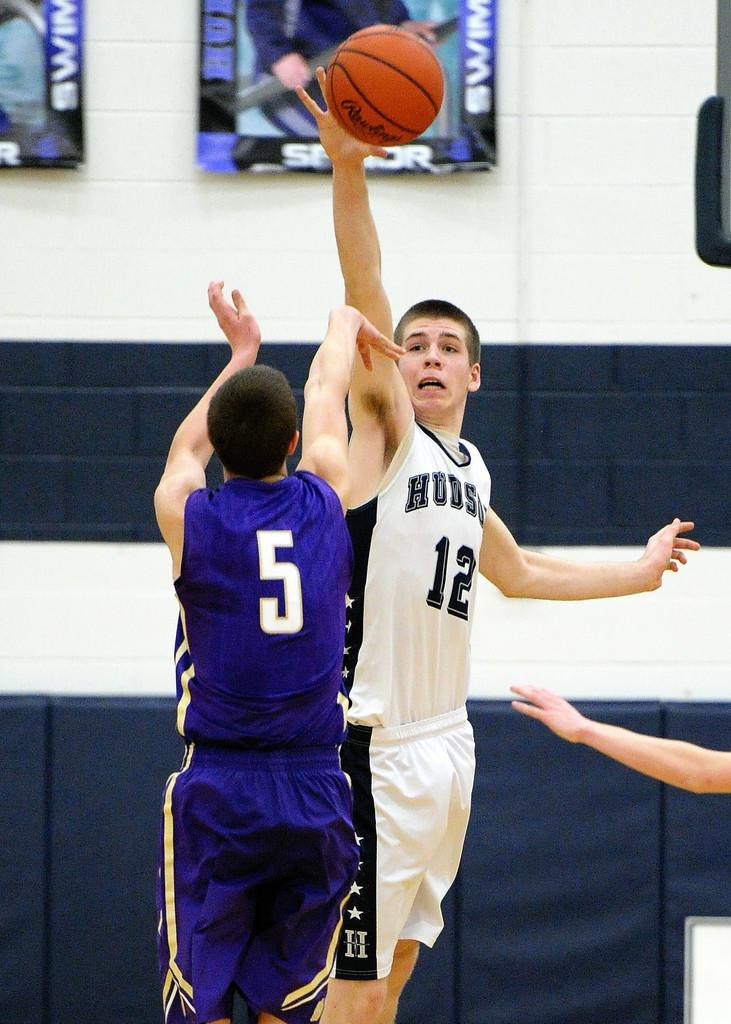<image>
Render a clear and concise summary of the photo. A man in a white Hudson jersey jumps for a basketball. 